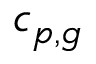<formula> <loc_0><loc_0><loc_500><loc_500>c _ { p , g }</formula> 